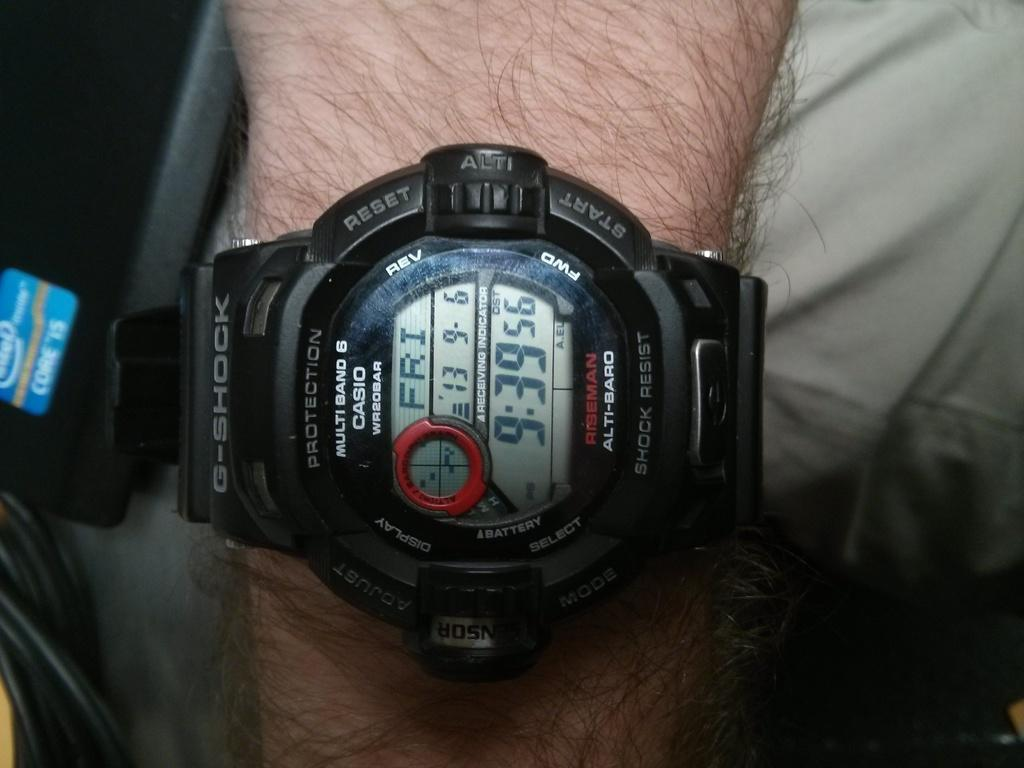<image>
Present a compact description of the photo's key features. A Casio watch on a man's wrist shows the time of 9:39. 